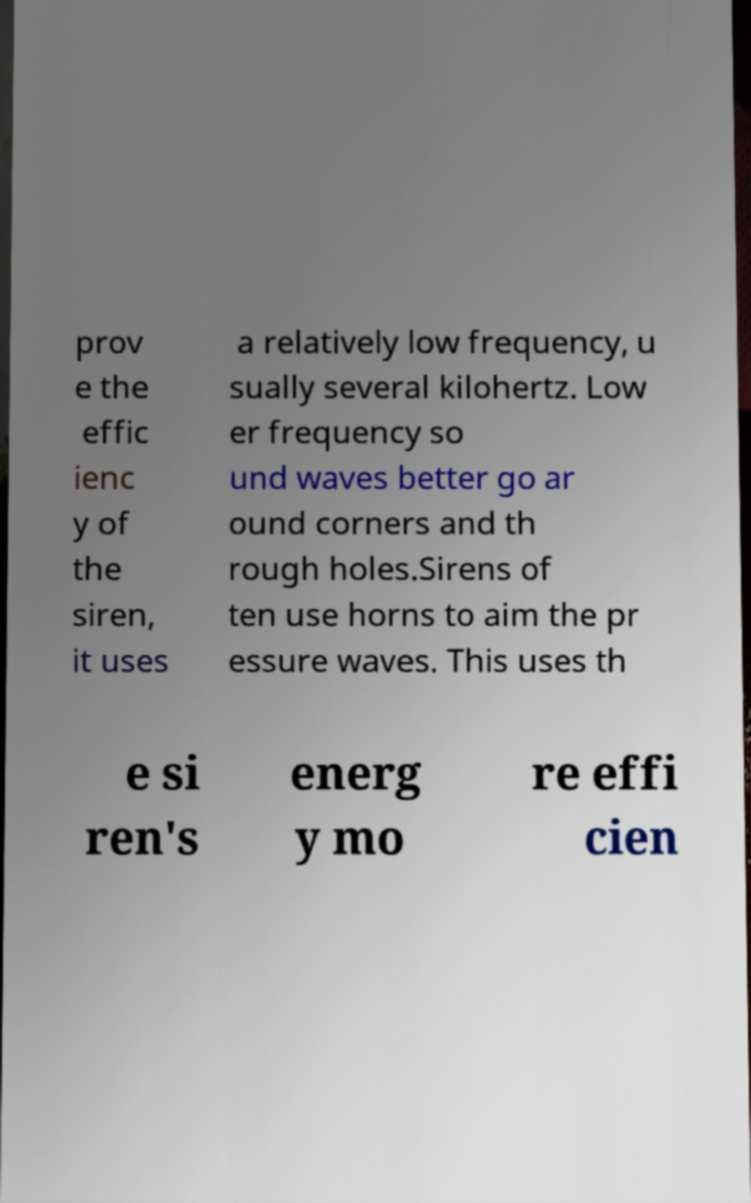What messages or text are displayed in this image? I need them in a readable, typed format. prov e the effic ienc y of the siren, it uses a relatively low frequency, u sually several kilohertz. Low er frequency so und waves better go ar ound corners and th rough holes.Sirens of ten use horns to aim the pr essure waves. This uses th e si ren's energ y mo re effi cien 